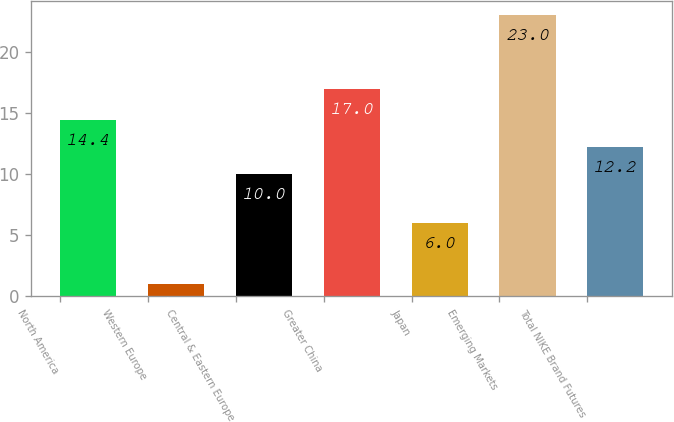Convert chart to OTSL. <chart><loc_0><loc_0><loc_500><loc_500><bar_chart><fcel>North America<fcel>Western Europe<fcel>Central & Eastern Europe<fcel>Greater China<fcel>Japan<fcel>Emerging Markets<fcel>Total NIKE Brand Futures<nl><fcel>14.4<fcel>1<fcel>10<fcel>17<fcel>6<fcel>23<fcel>12.2<nl></chart> 